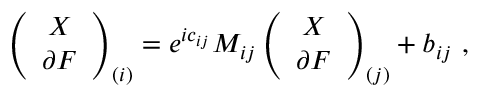Convert formula to latex. <formula><loc_0><loc_0><loc_500><loc_500>\left ( \begin{array} { c } { X } \\ { \partial F } \end{array} \right ) _ { ( i ) } = e ^ { i c _ { i j } } M _ { i j } \left ( \begin{array} { c } { X } \\ { \partial F } \end{array} \right ) _ { ( j ) } + b _ { i j } \ ,</formula> 